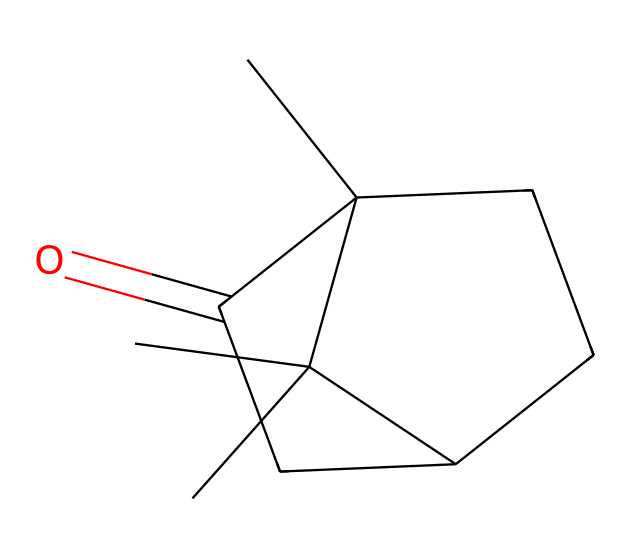What is the molecular formula of camphor based on the structure? To find the molecular formula, we need to count the number of each type of atom in the structure. From the SMILES representation, it can be determined that camphor contains 10 carbon atoms, 16 hydrogen atoms, and 1 oxygen atom, leading to a formula of C10H16O.
Answer: C10H16O How many rings are present in the structure of camphor? By inspecting the SMILES representation, we see that the numbers indicate ring closures. The shared numbers show two rings are formed, thus confirming the presence of two distinct rings.
Answer: 2 What functional group is characteristic of camphor? The presence of the carbonyl (C=O) group in the structure indicates that camphor is a ketone. This is a defining feature of ketones, distinguishing them from other functional groups.
Answer: ketone Is camphor a cyclic or acyclic compound? The presence of ring closures in the SMILES indicates that camphor features cyclic structure, as it consists of interconnected rings rather than being a linear chain.
Answer: cyclic What is the degree of unsaturation in camphor? The degree of unsaturation can be calculated by analyzing the rings and double bonds in the structure. The presence of two rings and one carbonyl group leads to a degree of unsaturation of 4.
Answer: 4 How many chiral centers does camphor have? By examining the structure for any carbon atom attached to four distinct substituents, we see that camphor has one such carbon, indicating it has one chiral center.
Answer: 1 